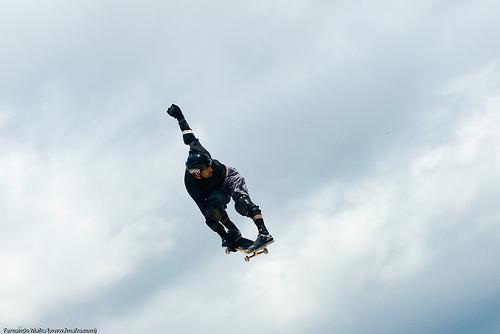How many men in the image?
Give a very brief answer. 1. 